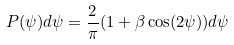<formula> <loc_0><loc_0><loc_500><loc_500>P ( \psi ) d \psi = \frac { 2 } { \pi } ( 1 + \beta \cos ( 2 \psi ) ) d \psi</formula> 